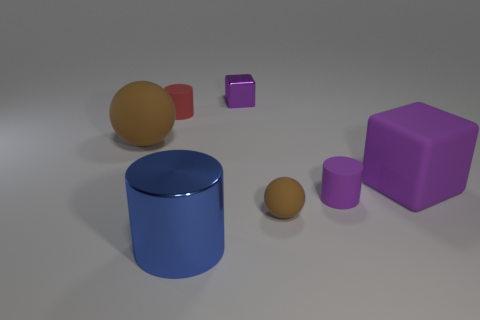Subtract all red cylinders. How many cylinders are left? 2 Add 1 purple rubber cylinders. How many objects exist? 8 Subtract all red cylinders. How many cylinders are left? 2 Subtract 0 brown cylinders. How many objects are left? 7 Subtract all spheres. How many objects are left? 5 Subtract 2 balls. How many balls are left? 0 Subtract all green spheres. Subtract all brown cylinders. How many spheres are left? 2 Subtract all blue spheres. How many cyan cylinders are left? 0 Subtract all red metallic things. Subtract all blue metal cylinders. How many objects are left? 6 Add 4 large brown things. How many large brown things are left? 5 